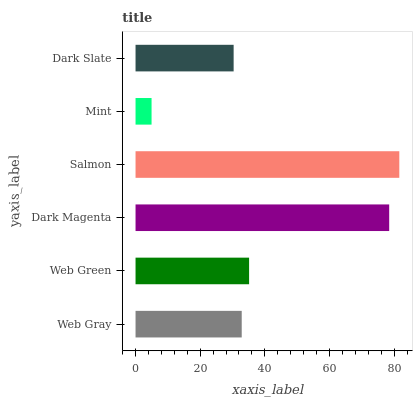Is Mint the minimum?
Answer yes or no. Yes. Is Salmon the maximum?
Answer yes or no. Yes. Is Web Green the minimum?
Answer yes or no. No. Is Web Green the maximum?
Answer yes or no. No. Is Web Green greater than Web Gray?
Answer yes or no. Yes. Is Web Gray less than Web Green?
Answer yes or no. Yes. Is Web Gray greater than Web Green?
Answer yes or no. No. Is Web Green less than Web Gray?
Answer yes or no. No. Is Web Green the high median?
Answer yes or no. Yes. Is Web Gray the low median?
Answer yes or no. Yes. Is Mint the high median?
Answer yes or no. No. Is Dark Slate the low median?
Answer yes or no. No. 